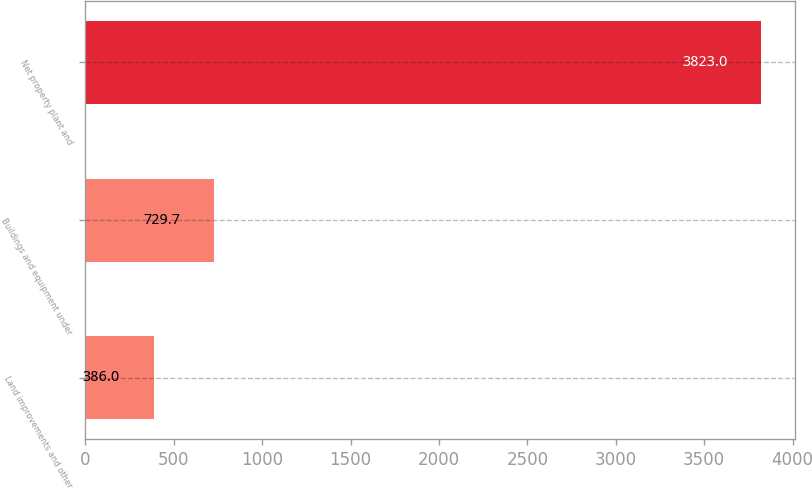Convert chart. <chart><loc_0><loc_0><loc_500><loc_500><bar_chart><fcel>Land improvements and other<fcel>Buildings and equipment under<fcel>Net property plant and<nl><fcel>386<fcel>729.7<fcel>3823<nl></chart> 